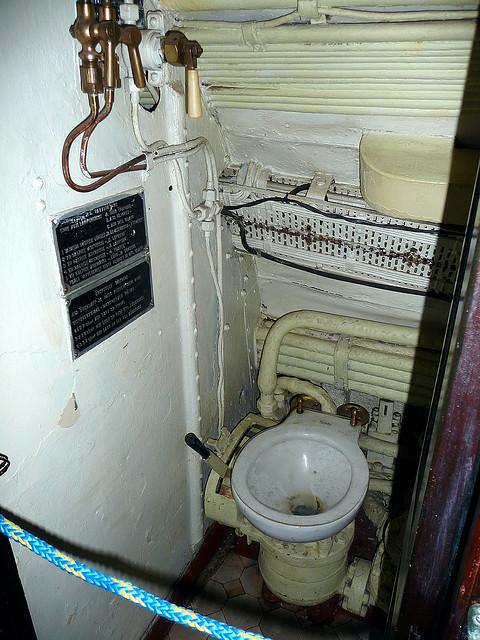Does the rope cast a shadow?
Be succinct. Yes. What is wrong with this bathroom?
Be succinct. Dirty. Is this a kitchen, garage, or toilet area?
Concise answer only. Toilet. Rope is nylon or not?
Give a very brief answer. Yes. 